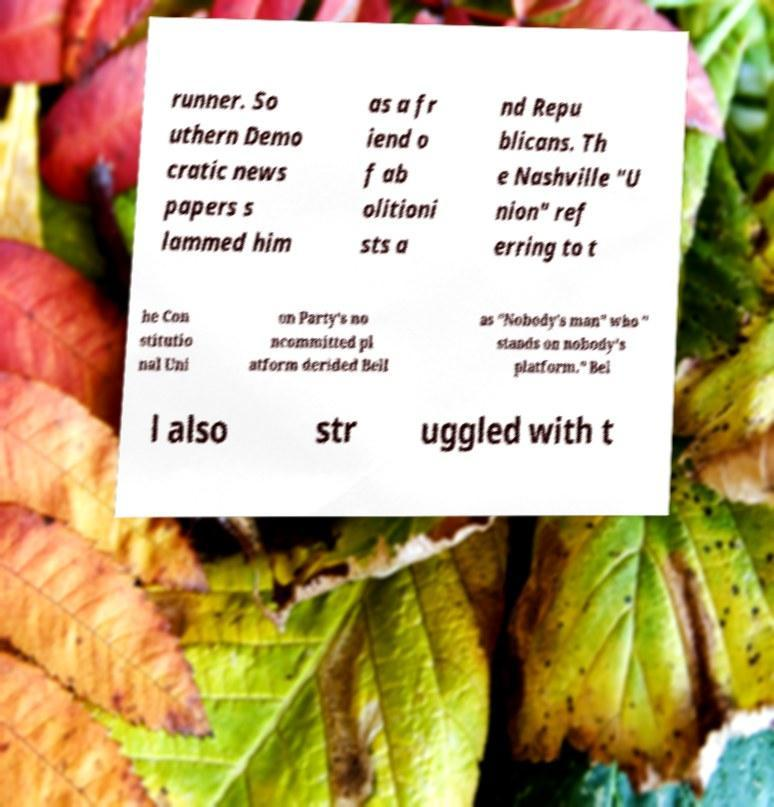I need the written content from this picture converted into text. Can you do that? runner. So uthern Demo cratic news papers s lammed him as a fr iend o f ab olitioni sts a nd Repu blicans. Th e Nashville "U nion" ref erring to t he Con stitutio nal Uni on Party's no ncommitted pl atform derided Bell as "Nobody's man" who " stands on nobody's platform." Bel l also str uggled with t 